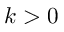Convert formula to latex. <formula><loc_0><loc_0><loc_500><loc_500>k > 0</formula> 